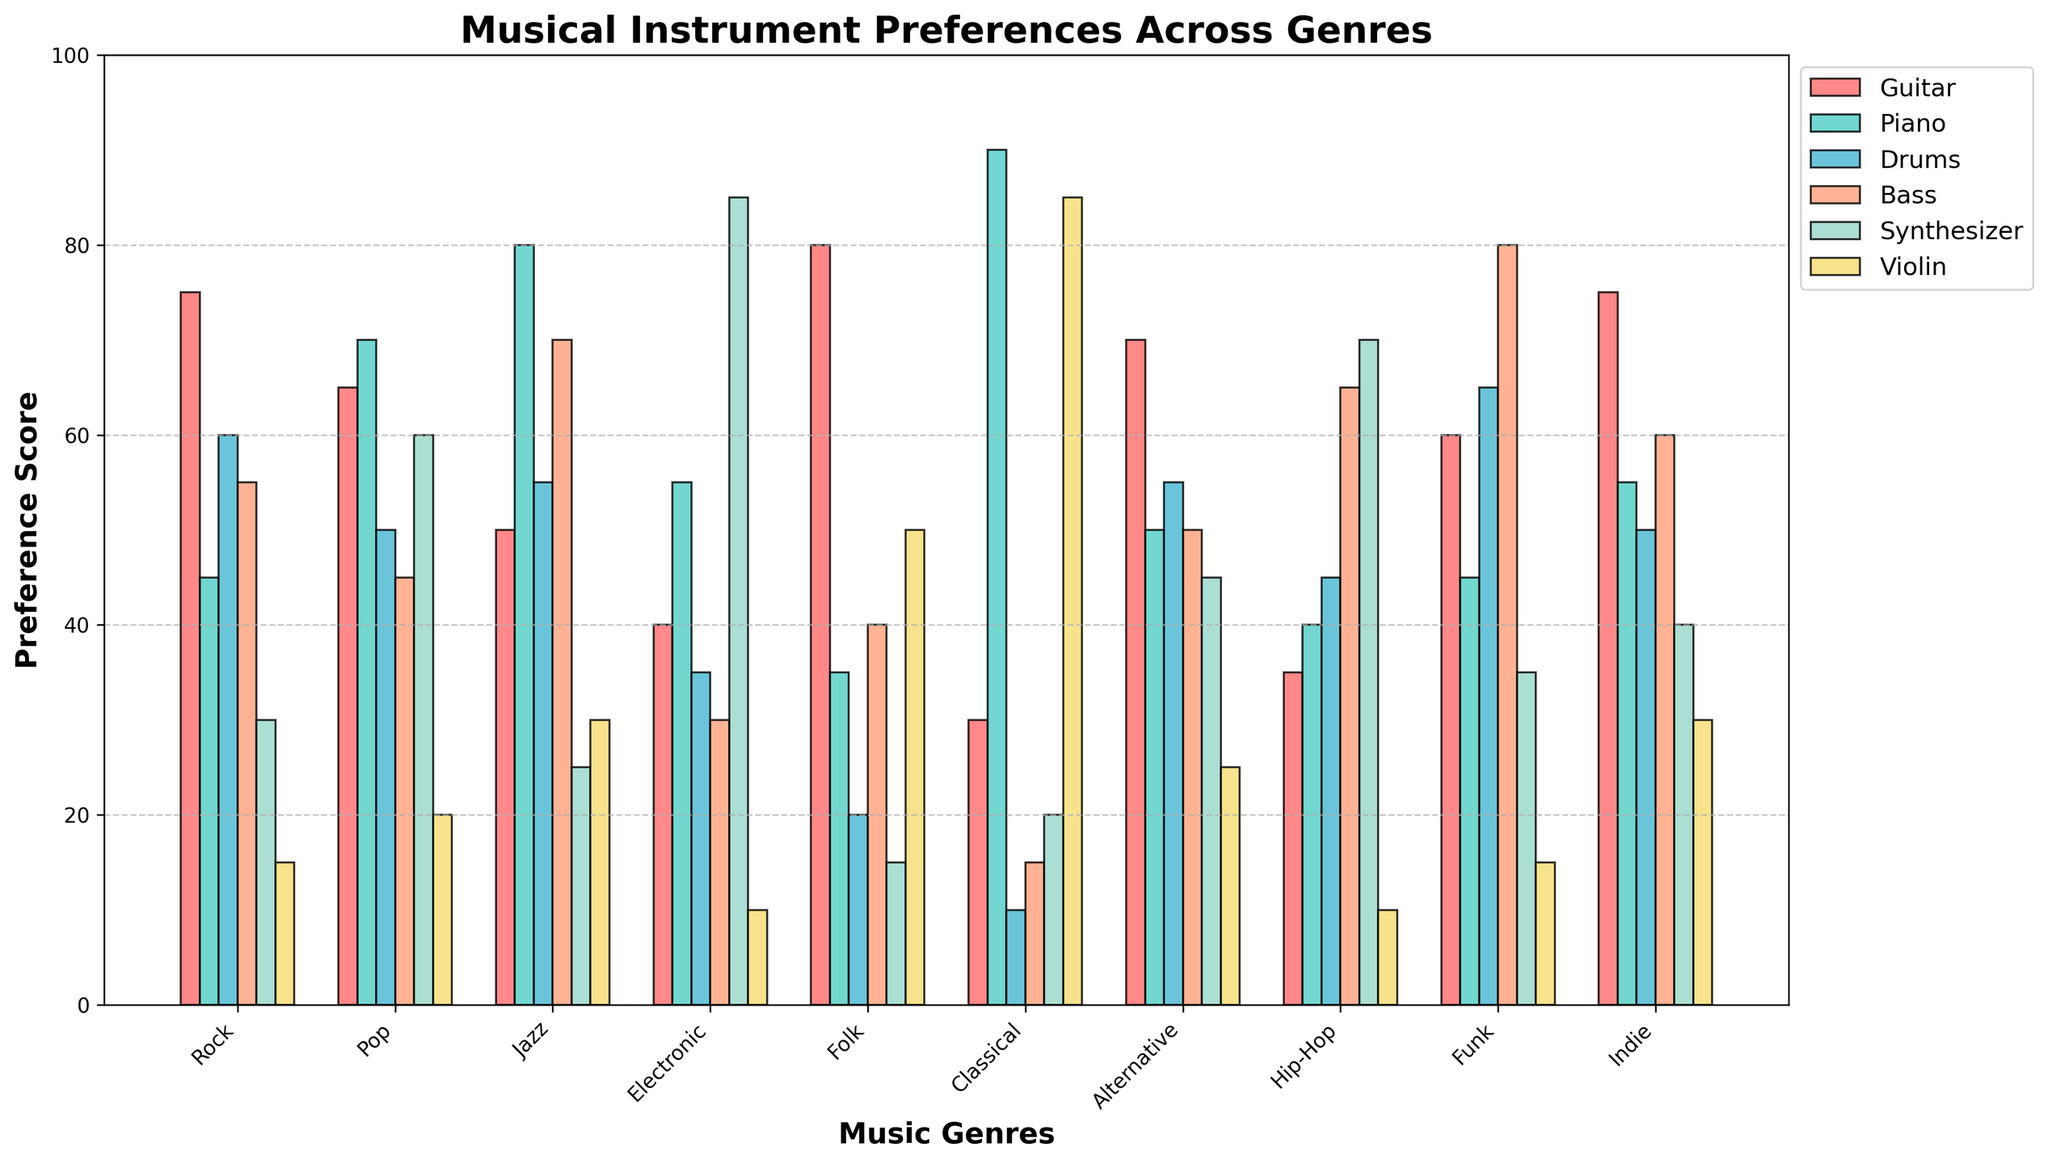Which genre has the highest preference for the Synthesizer? To determine this, find the highest bar corresponding to the Synthesizer for each genre. The tallest bar is in the Electronic genre.
Answer: Electronic Which instrument is most preferred in the Folk genre? Look for the highest bar in the Folk genre column. The highest bar is for the Guitar.
Answer: Guitar What is the difference in preference between Drums in Rock and Pop genres? Identify the height of the Drums bars for both the Rock and Pop genres. The values are 60 (Rock) and 50 (Pop). Calculate the difference: 60 - 50 = 10.
Answer: 10 Which genre has the least preference for the Violin? Find the shortest bar in the Violin category across all the genres. The shortest bar is in the Electronic genre.
Answer: Electronic What is the combined preference score for Guitar and Piano in the Jazz genre? Locate the Jazz genre and find the preference scores for the Guitar and Piano. They are 50 (Guitar) and 80 (Piano). Sum them: 50 + 80 = 130.
Answer: 130 Which instrument has the smallest range of preference scores across all genres? Calculate the range (maximum value minus minimum value) for each instrument. The ranges are as follows: Guitar: 80-30=50, Piano: 90-35=55, Drums: 65-10=55, Bass: 80-15=65, Synthesizer: 85-15=70, Violin: 85-10=75. The smallest range is for the Guitar.
Answer: Guitar Is the preference for the Piano higher in Hip-Hop or Indie genres? Compare the height of the Piano bars for Hip-Hop and Indie genres. The scores are 40 (Hip-Hop) and 55 (Indie). The Indie genre has a higher preference for the Piano.
Answer: Indie What is the average preference score for the Synthesizer across all genres? Sum all the Synthesizer preference scores and divide by the number of genres: (30 + 60 + 25 + 85 + 15 + 20 + 45 + 70 + 35 + 40) / 10 = 42.5.
Answer: 42.5 Which genre shows the most balanced preference across all instruments? Identify the genre with the smallest difference between the highest and lowest preference scores for its instruments. Calculate the ranges: Rock: 75-15=60, Pop: 70-20=50, Jazz: 80-25=55, Electronic: 85-10=75, Folk: 80-15=65, Classical: 90-10=80, Alternative: 70-25=45, Hip-Hop: 70-10=60, Funk: 80-15=65, Indie: 75-30=45. The most balanced genres are Alternative and Indie.
Answer: Alternative and Indie 